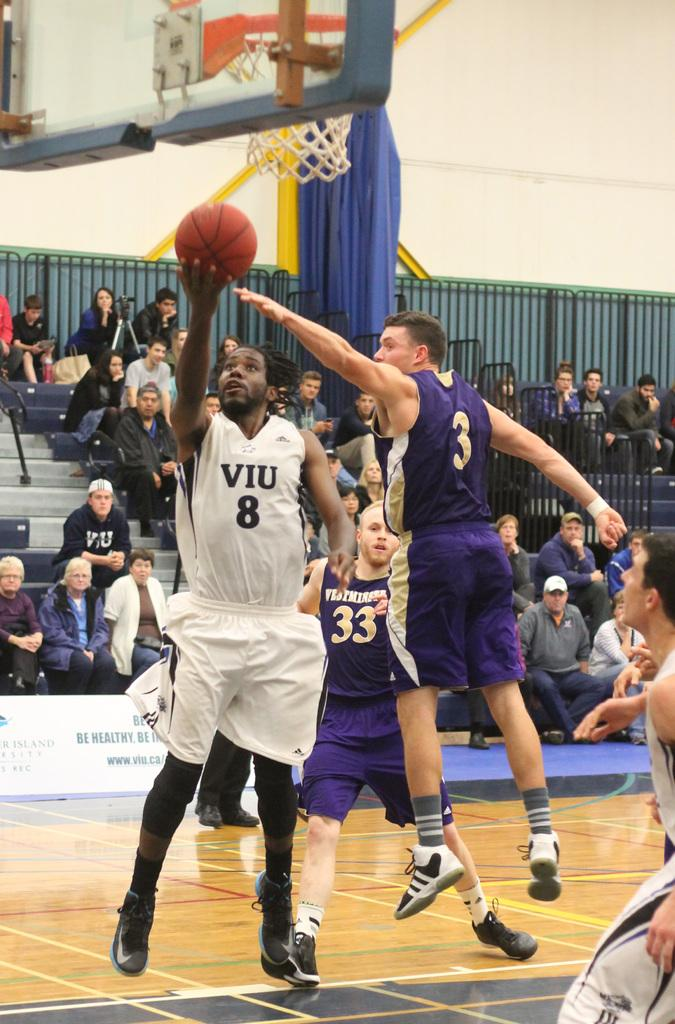<image>
Render a clear and concise summary of the photo. Men are playing basketball and one has the number 8 on his jersey. 